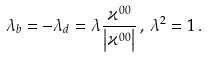<formula> <loc_0><loc_0><loc_500><loc_500>\lambda _ { b } = - \lambda _ { d } = \lambda \frac { \varkappa ^ { 0 0 } } { \left | \varkappa ^ { 0 0 } \right | } \, , \, \lambda ^ { 2 } = 1 \, .</formula> 